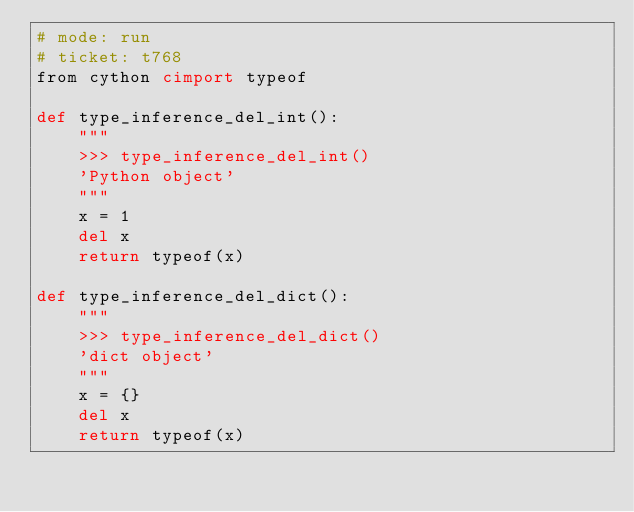<code> <loc_0><loc_0><loc_500><loc_500><_Cython_># mode: run
# ticket: t768
from cython cimport typeof

def type_inference_del_int():
    """
    >>> type_inference_del_int()
    'Python object'
    """
    x = 1
    del x
    return typeof(x)

def type_inference_del_dict():
    """
    >>> type_inference_del_dict()
    'dict object'
    """
    x = {}
    del x
    return typeof(x)
</code> 